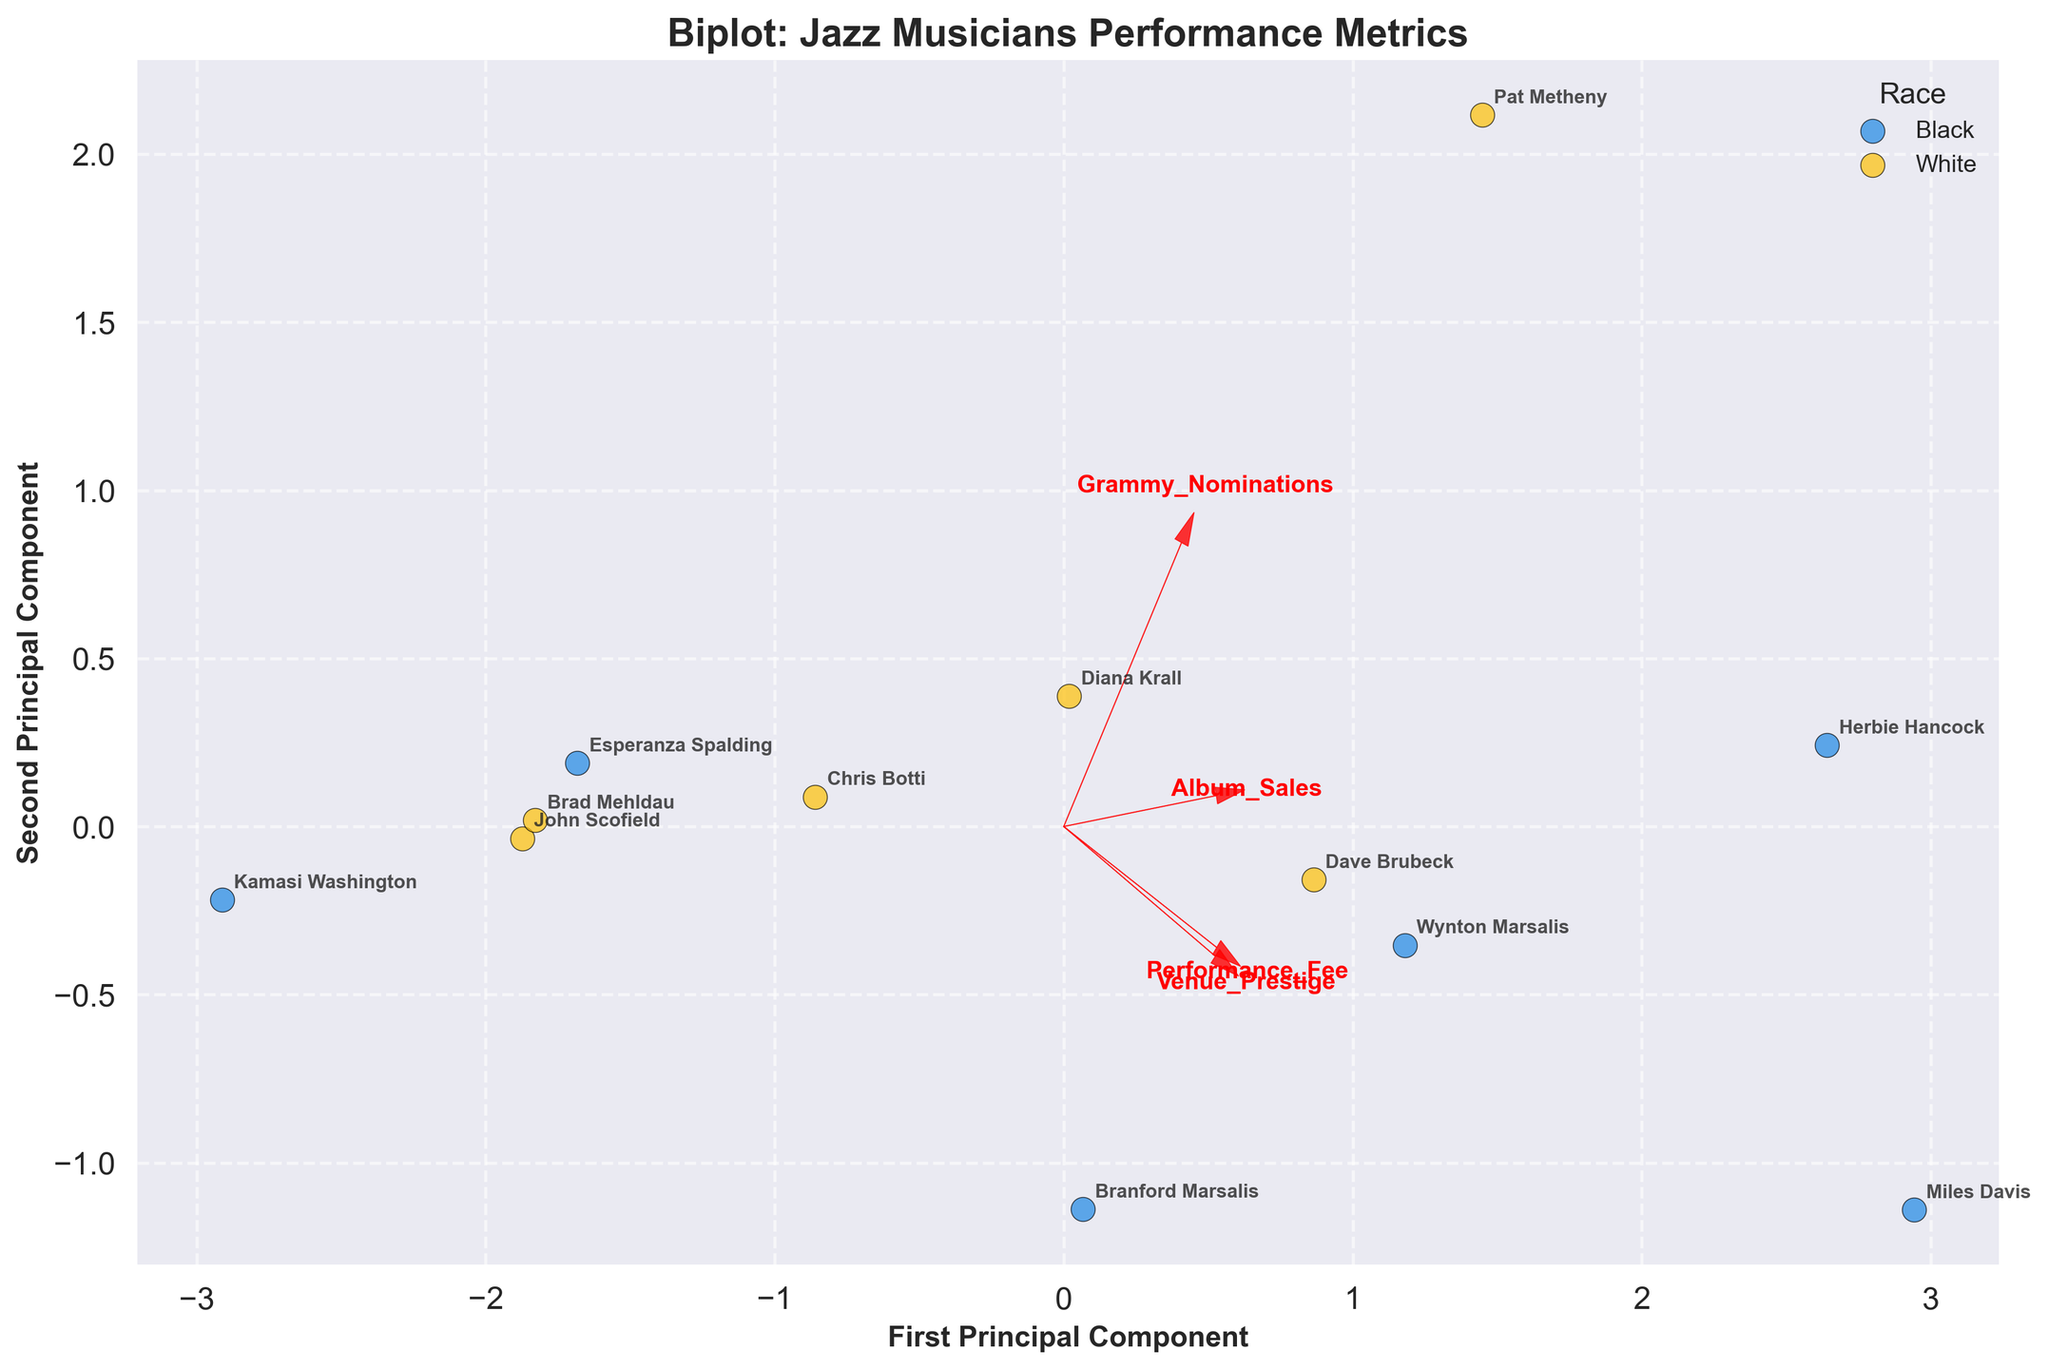How many racial groups are displayed in the plot? The plot uses different colors to distinguish between racial groups. By counting the unique colors (blue and yellow), we identify two racial groups.
Answer: Two What does the first principal component axis primarily represent in this biplot? Observing the red vectors, the first principal component has strong contributions from 'Performance_Fee' and 'Album_Sales,' indicating these metrics primarily influence this axis.
Answer: Performance earning and album sales Which race generally performs better in terms of venue prestige? By looking at the data points and their positions along the Venue_Prestige vector, Black musicians generally appear closer to the higher values (9-9.5).
Answer: Black musicians Comparing the variances in 'Performance_Fee' and 'Venue_Prestige,' can a particular trend be seen among racial groups? Analyzing the spread of the data points and the direction of the vectors, Black musicians tend to have higher venue prestige and performance fees, whereas White musicians have slightly lower values.
Answer: Black musicians have higher values Which musician appears to have the highest combination of first and second principal component scores? Looking at the furthest data point along the principal components, Herbie Hancock (Black) seems to have the highest combination of both scores.
Answer: Herbie Hancock Do any musicians appear closely clustered in the biplot, and what might this suggest? Observing the data point clusters, Diana Krall and Chris Botti (both White) are closely clustered, suggesting their metrics are quite similar across the features.
Answer: Diana Krall and Chris Botti Do Grammy nominations significantly contribute to the principal components? By examining the length of the vector for Grammy_Nominations, it is relatively shorter compared to others, indicating a lesser contribution to the principal components.
Answer: No Which feature contributes least to the second principal component? By observing the length and angle of the vector arrows, the 'Grammy_Nominations' vector is almost perpendicular to the second principal component, suggesting a minimal contribution.
Answer: Grammy nominations Based on the biplot, can we infer any racial disparity in the jazz music industry related to performance metrics? Observing the separation and clustering in the biplot, Black musicians generally have higher performance fees and venue prestige, showcasing some disparity in favor of Black musicians in these metrics.
Answer: Yes, in favor of Black musicians 